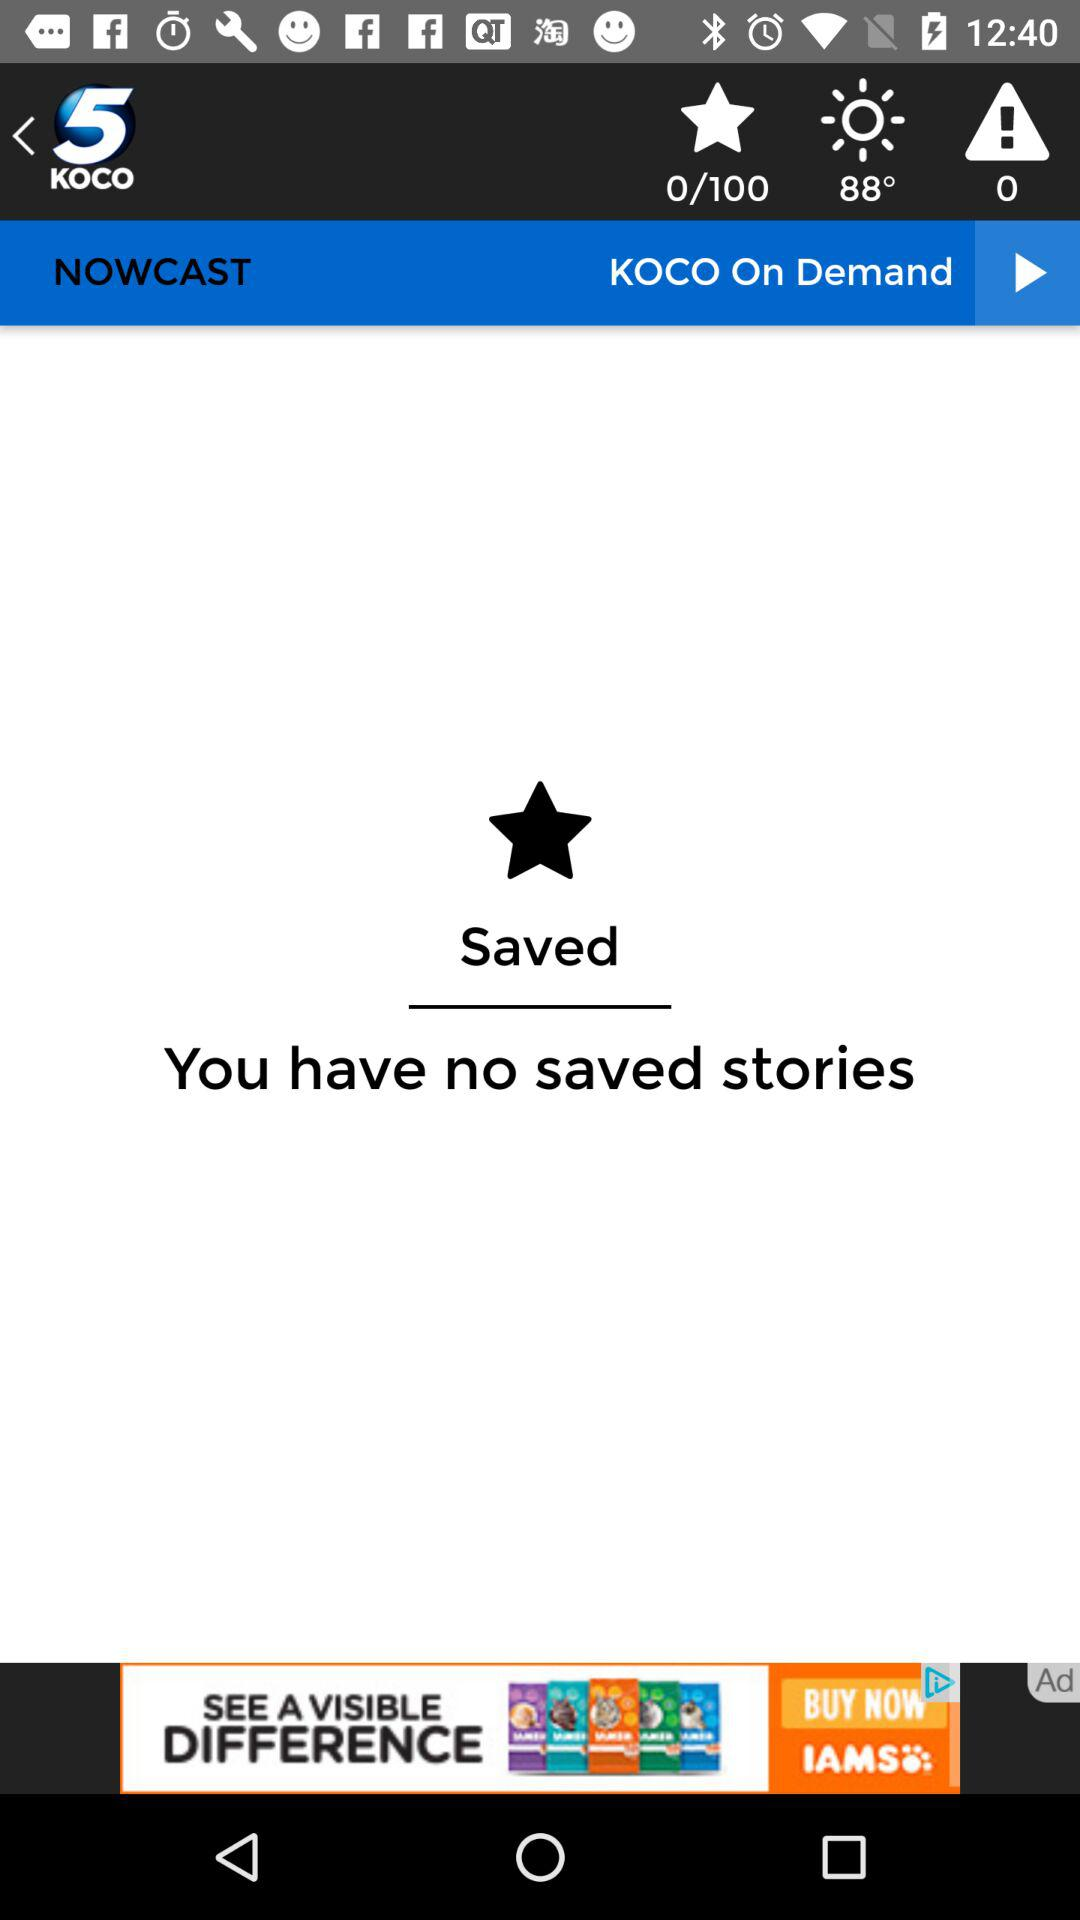How many total star pages? There are 100 total star pages. 